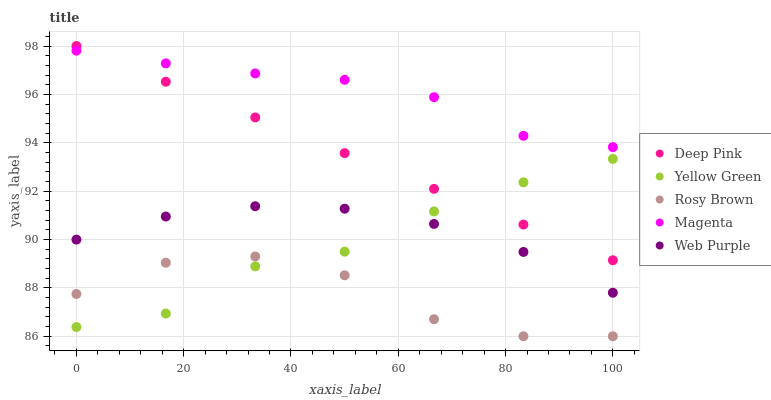Does Rosy Brown have the minimum area under the curve?
Answer yes or no. Yes. Does Magenta have the maximum area under the curve?
Answer yes or no. Yes. Does Deep Pink have the minimum area under the curve?
Answer yes or no. No. Does Deep Pink have the maximum area under the curve?
Answer yes or no. No. Is Deep Pink the smoothest?
Answer yes or no. Yes. Is Rosy Brown the roughest?
Answer yes or no. Yes. Is Rosy Brown the smoothest?
Answer yes or no. No. Is Deep Pink the roughest?
Answer yes or no. No. Does Rosy Brown have the lowest value?
Answer yes or no. Yes. Does Deep Pink have the lowest value?
Answer yes or no. No. Does Deep Pink have the highest value?
Answer yes or no. Yes. Does Rosy Brown have the highest value?
Answer yes or no. No. Is Web Purple less than Deep Pink?
Answer yes or no. Yes. Is Magenta greater than Rosy Brown?
Answer yes or no. Yes. Does Magenta intersect Deep Pink?
Answer yes or no. Yes. Is Magenta less than Deep Pink?
Answer yes or no. No. Is Magenta greater than Deep Pink?
Answer yes or no. No. Does Web Purple intersect Deep Pink?
Answer yes or no. No. 